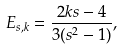Convert formula to latex. <formula><loc_0><loc_0><loc_500><loc_500>E _ { s , k } = \frac { 2 k s - 4 } { 3 ( s ^ { 2 } - 1 ) } ,</formula> 